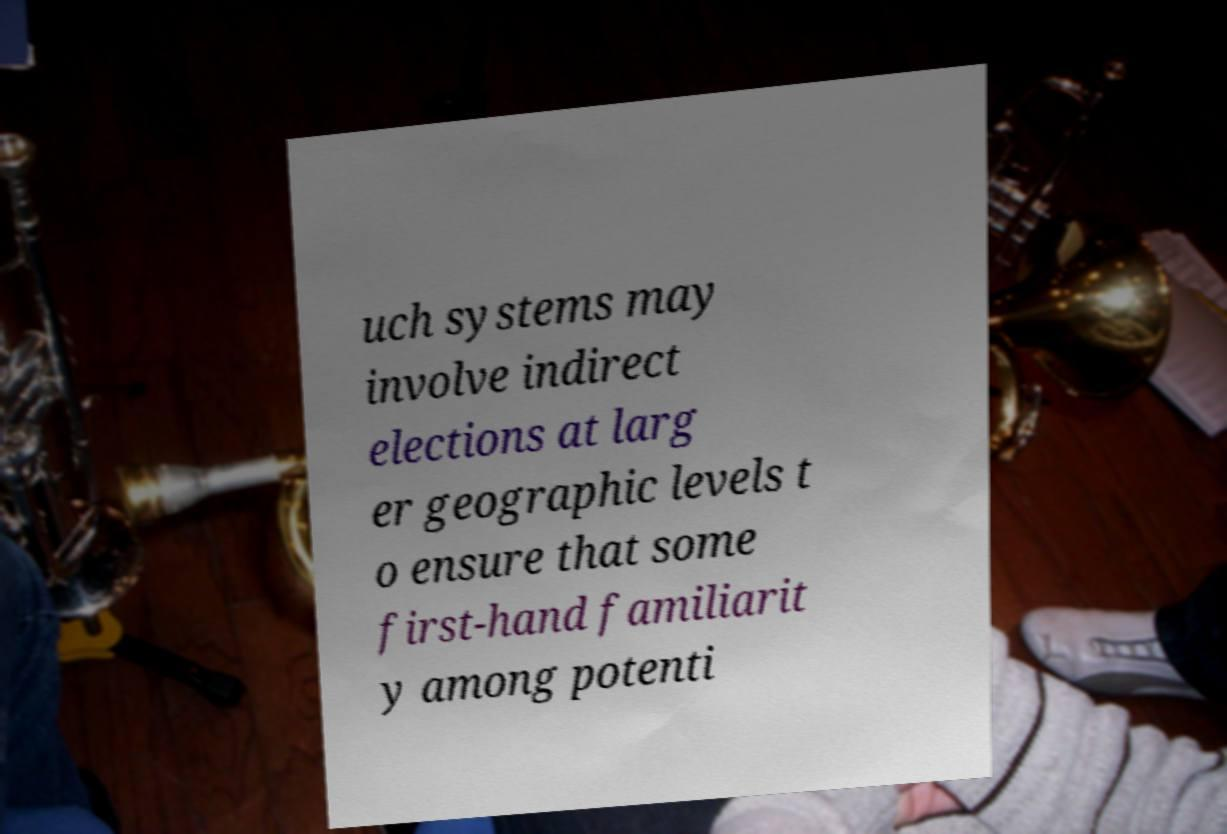Can you accurately transcribe the text from the provided image for me? uch systems may involve indirect elections at larg er geographic levels t o ensure that some first-hand familiarit y among potenti 